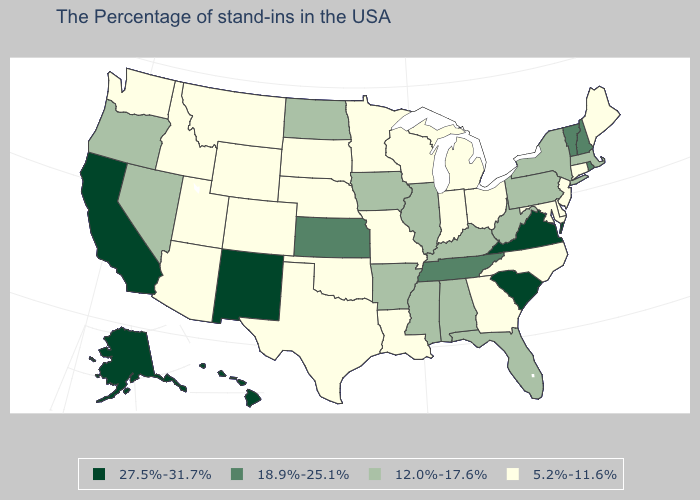What is the value of Utah?
Short answer required. 5.2%-11.6%. Name the states that have a value in the range 5.2%-11.6%?
Keep it brief. Maine, Connecticut, New Jersey, Delaware, Maryland, North Carolina, Ohio, Georgia, Michigan, Indiana, Wisconsin, Louisiana, Missouri, Minnesota, Nebraska, Oklahoma, Texas, South Dakota, Wyoming, Colorado, Utah, Montana, Arizona, Idaho, Washington. Among the states that border Connecticut , which have the highest value?
Quick response, please. Rhode Island. What is the value of Arkansas?
Short answer required. 12.0%-17.6%. How many symbols are there in the legend?
Be succinct. 4. Among the states that border New Hampshire , does Maine have the highest value?
Write a very short answer. No. What is the lowest value in states that border South Dakota?
Write a very short answer. 5.2%-11.6%. Name the states that have a value in the range 27.5%-31.7%?
Short answer required. Virginia, South Carolina, New Mexico, California, Alaska, Hawaii. How many symbols are there in the legend?
Be succinct. 4. Which states have the highest value in the USA?
Be succinct. Virginia, South Carolina, New Mexico, California, Alaska, Hawaii. What is the value of Minnesota?
Write a very short answer. 5.2%-11.6%. What is the highest value in the USA?
Answer briefly. 27.5%-31.7%. What is the highest value in the South ?
Short answer required. 27.5%-31.7%. Among the states that border Florida , does Georgia have the lowest value?
Keep it brief. Yes. Which states have the lowest value in the USA?
Be succinct. Maine, Connecticut, New Jersey, Delaware, Maryland, North Carolina, Ohio, Georgia, Michigan, Indiana, Wisconsin, Louisiana, Missouri, Minnesota, Nebraska, Oklahoma, Texas, South Dakota, Wyoming, Colorado, Utah, Montana, Arizona, Idaho, Washington. 